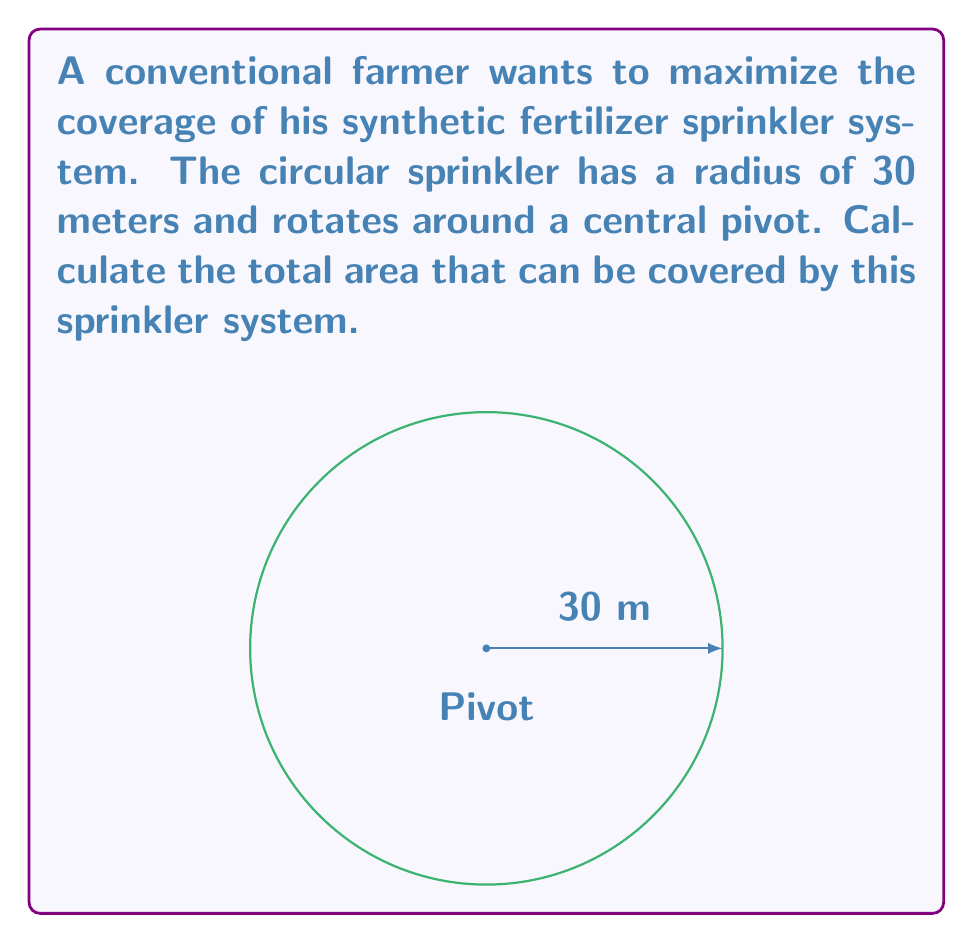What is the answer to this math problem? To calculate the area covered by the circular sprinkler system, we need to use the formula for the area of a circle:

$$A = \pi r^2$$

Where:
$A$ = area
$\pi$ = pi (approximately 3.14159)
$r$ = radius of the circle

Given:
- Radius of the sprinkler system = 30 meters

Step 1: Substitute the given radius into the formula.
$$A = \pi (30)^2$$

Step 2: Calculate the square of the radius.
$$A = \pi (900)$$

Step 3: Multiply by π.
$$A = 2827.43 \text{ m}^2$$

Step 4: Round to the nearest whole number for practical purposes.
$$A \approx 2827 \text{ m}^2$$

This result represents the total area that can be covered by the circular sprinkler system, allowing for efficient distribution of synthetic fertilizers across the field.
Answer: $2827 \text{ m}^2$ 